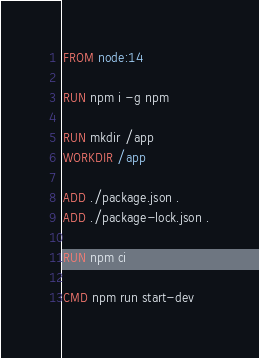Convert code to text. <code><loc_0><loc_0><loc_500><loc_500><_Dockerfile_>FROM node:14

RUN npm i -g npm

RUN mkdir /app
WORKDIR /app

ADD ./package.json .
ADD ./package-lock.json .

RUN npm ci

CMD npm run start-dev
</code> 